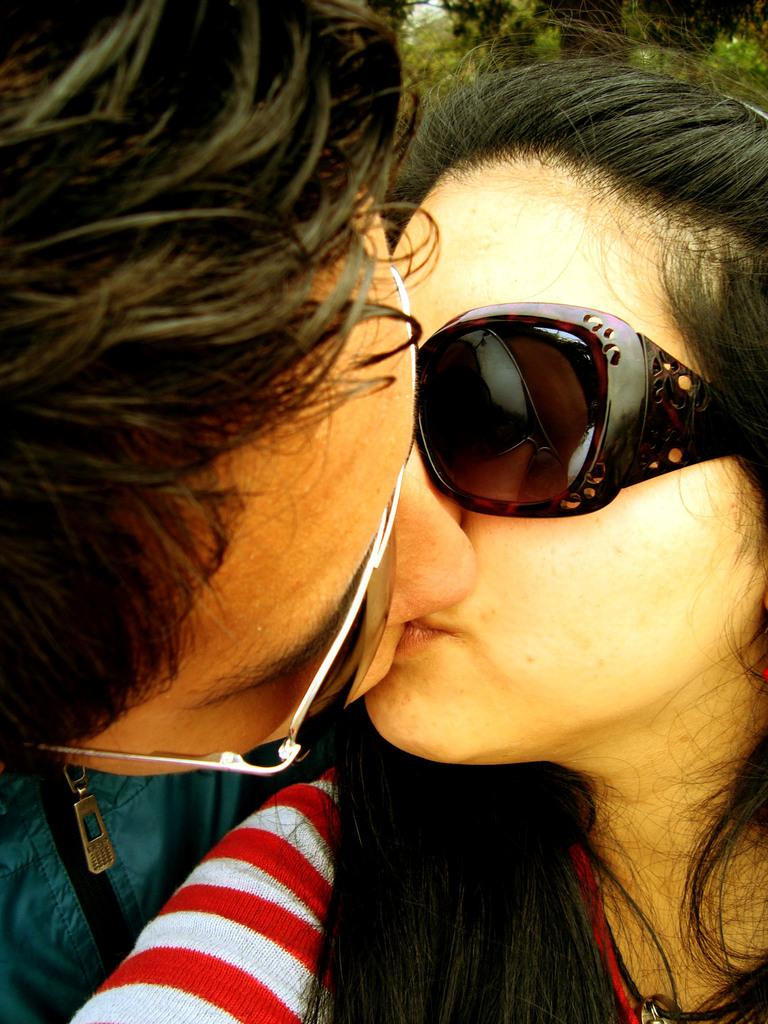How many people are in the image? There are two people in the image. What are the two people doing in the image? The two people are kissing each other. What can be observed about the appearance of the two people? Both people are wearing spectacles. What type of cable is visible in the image? There is no cable present in the image. What form of respect is being shown in the image? The image does not depict a specific form of respect; it shows two people kissing each other. 